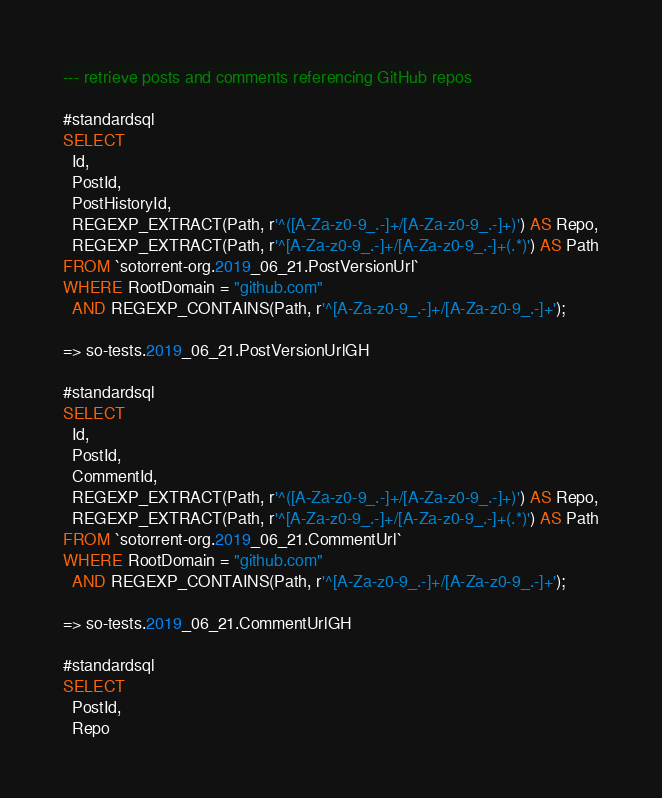Convert code to text. <code><loc_0><loc_0><loc_500><loc_500><_SQL_>--- retrieve posts and comments referencing GitHub repos

#standardsql
SELECT
  Id,
  PostId,
  PostHistoryId, 
  REGEXP_EXTRACT(Path, r'^([A-Za-z0-9_.-]+/[A-Za-z0-9_.-]+)') AS Repo,
  REGEXP_EXTRACT(Path, r'^[A-Za-z0-9_.-]+/[A-Za-z0-9_.-]+(.*)') AS Path
FROM `sotorrent-org.2019_06_21.PostVersionUrl`
WHERE RootDomain = "github.com"
  AND REGEXP_CONTAINS(Path, r'^[A-Za-z0-9_.-]+/[A-Za-z0-9_.-]+'); 
  
=> so-tests.2019_06_21.PostVersionUrlGH

#standardsql
SELECT
  Id,
  PostId,
  CommentId, 
  REGEXP_EXTRACT(Path, r'^([A-Za-z0-9_.-]+/[A-Za-z0-9_.-]+)') AS Repo,
  REGEXP_EXTRACT(Path, r'^[A-Za-z0-9_.-]+/[A-Za-z0-9_.-]+(.*)') AS Path
FROM `sotorrent-org.2019_06_21.CommentUrl`
WHERE RootDomain = "github.com"
  AND REGEXP_CONTAINS(Path, r'^[A-Za-z0-9_.-]+/[A-Za-z0-9_.-]+'); 
  
=> so-tests.2019_06_21.CommentUrlGH

#standardsql
SELECT
  PostId,
  Repo</code> 